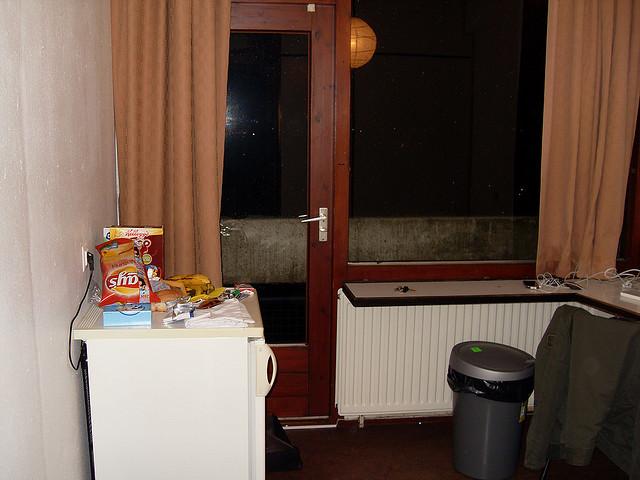What time is it?
Be succinct. Night. What kind of chips are on the table?
Keep it brief. Lays. Is there a trash receptacle in the room?
Short answer required. Yes. Is there a light on outside?
Short answer required. Yes. 